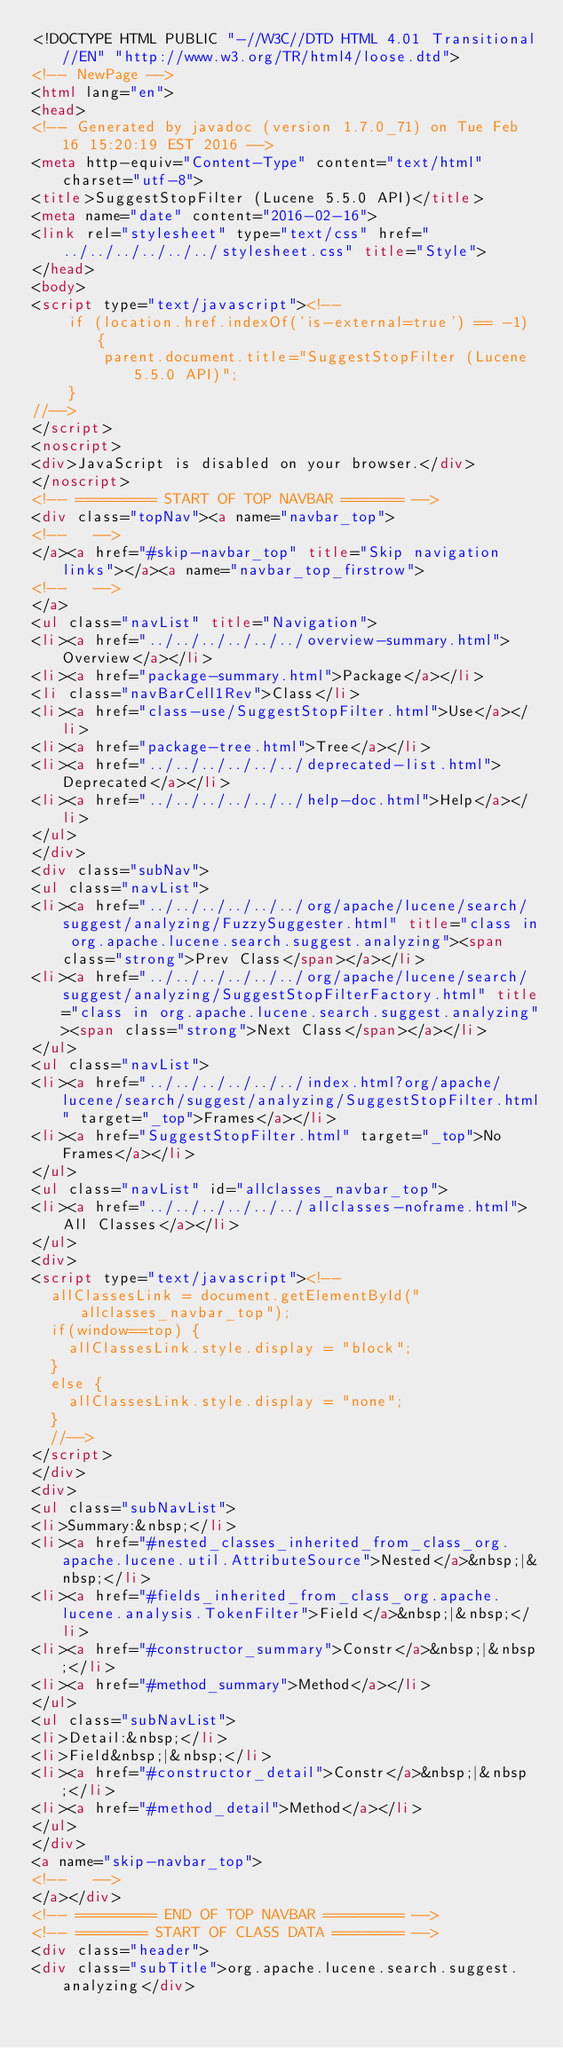Convert code to text. <code><loc_0><loc_0><loc_500><loc_500><_HTML_><!DOCTYPE HTML PUBLIC "-//W3C//DTD HTML 4.01 Transitional//EN" "http://www.w3.org/TR/html4/loose.dtd">
<!-- NewPage -->
<html lang="en">
<head>
<!-- Generated by javadoc (version 1.7.0_71) on Tue Feb 16 15:20:19 EST 2016 -->
<meta http-equiv="Content-Type" content="text/html" charset="utf-8">
<title>SuggestStopFilter (Lucene 5.5.0 API)</title>
<meta name="date" content="2016-02-16">
<link rel="stylesheet" type="text/css" href="../../../../../../stylesheet.css" title="Style">
</head>
<body>
<script type="text/javascript"><!--
    if (location.href.indexOf('is-external=true') == -1) {
        parent.document.title="SuggestStopFilter (Lucene 5.5.0 API)";
    }
//-->
</script>
<noscript>
<div>JavaScript is disabled on your browser.</div>
</noscript>
<!-- ========= START OF TOP NAVBAR ======= -->
<div class="topNav"><a name="navbar_top">
<!--   -->
</a><a href="#skip-navbar_top" title="Skip navigation links"></a><a name="navbar_top_firstrow">
<!--   -->
</a>
<ul class="navList" title="Navigation">
<li><a href="../../../../../../overview-summary.html">Overview</a></li>
<li><a href="package-summary.html">Package</a></li>
<li class="navBarCell1Rev">Class</li>
<li><a href="class-use/SuggestStopFilter.html">Use</a></li>
<li><a href="package-tree.html">Tree</a></li>
<li><a href="../../../../../../deprecated-list.html">Deprecated</a></li>
<li><a href="../../../../../../help-doc.html">Help</a></li>
</ul>
</div>
<div class="subNav">
<ul class="navList">
<li><a href="../../../../../../org/apache/lucene/search/suggest/analyzing/FuzzySuggester.html" title="class in org.apache.lucene.search.suggest.analyzing"><span class="strong">Prev Class</span></a></li>
<li><a href="../../../../../../org/apache/lucene/search/suggest/analyzing/SuggestStopFilterFactory.html" title="class in org.apache.lucene.search.suggest.analyzing"><span class="strong">Next Class</span></a></li>
</ul>
<ul class="navList">
<li><a href="../../../../../../index.html?org/apache/lucene/search/suggest/analyzing/SuggestStopFilter.html" target="_top">Frames</a></li>
<li><a href="SuggestStopFilter.html" target="_top">No Frames</a></li>
</ul>
<ul class="navList" id="allclasses_navbar_top">
<li><a href="../../../../../../allclasses-noframe.html">All Classes</a></li>
</ul>
<div>
<script type="text/javascript"><!--
  allClassesLink = document.getElementById("allclasses_navbar_top");
  if(window==top) {
    allClassesLink.style.display = "block";
  }
  else {
    allClassesLink.style.display = "none";
  }
  //-->
</script>
</div>
<div>
<ul class="subNavList">
<li>Summary:&nbsp;</li>
<li><a href="#nested_classes_inherited_from_class_org.apache.lucene.util.AttributeSource">Nested</a>&nbsp;|&nbsp;</li>
<li><a href="#fields_inherited_from_class_org.apache.lucene.analysis.TokenFilter">Field</a>&nbsp;|&nbsp;</li>
<li><a href="#constructor_summary">Constr</a>&nbsp;|&nbsp;</li>
<li><a href="#method_summary">Method</a></li>
</ul>
<ul class="subNavList">
<li>Detail:&nbsp;</li>
<li>Field&nbsp;|&nbsp;</li>
<li><a href="#constructor_detail">Constr</a>&nbsp;|&nbsp;</li>
<li><a href="#method_detail">Method</a></li>
</ul>
</div>
<a name="skip-navbar_top">
<!--   -->
</a></div>
<!-- ========= END OF TOP NAVBAR ========= -->
<!-- ======== START OF CLASS DATA ======== -->
<div class="header">
<div class="subTitle">org.apache.lucene.search.suggest.analyzing</div></code> 